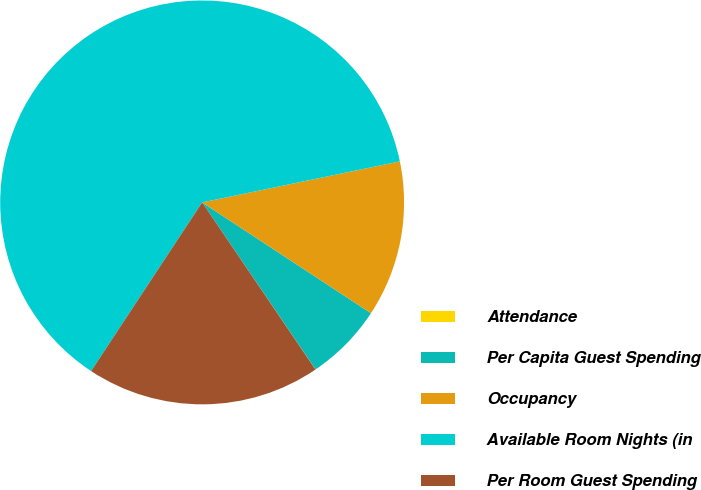Convert chart to OTSL. <chart><loc_0><loc_0><loc_500><loc_500><pie_chart><fcel>Attendance<fcel>Per Capita Guest Spending<fcel>Occupancy<fcel>Available Room Nights (in<fcel>Per Room Guest Spending<nl><fcel>0.01%<fcel>6.26%<fcel>12.5%<fcel>62.47%<fcel>18.75%<nl></chart> 